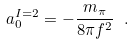Convert formula to latex. <formula><loc_0><loc_0><loc_500><loc_500>a _ { 0 } ^ { I = 2 } = - \frac { m _ { \pi } } { 8 \pi f ^ { 2 } } \ .</formula> 